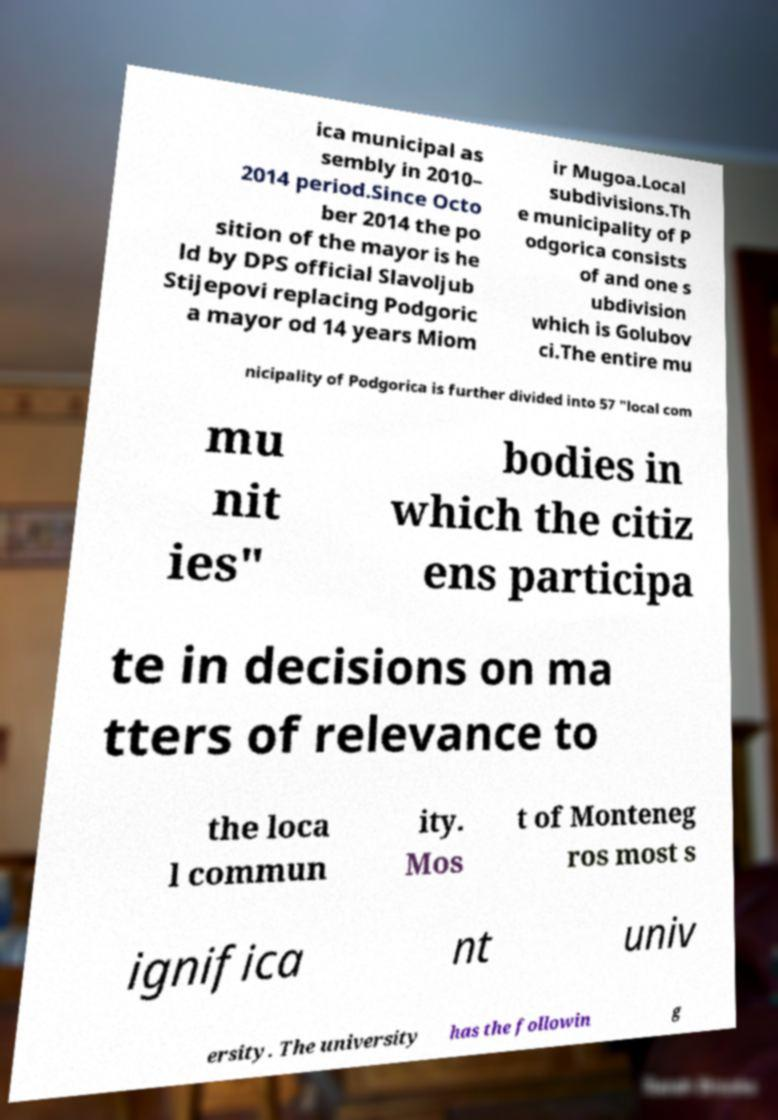For documentation purposes, I need the text within this image transcribed. Could you provide that? ica municipal as sembly in 2010– 2014 period.Since Octo ber 2014 the po sition of the mayor is he ld by DPS official Slavoljub Stijepovi replacing Podgoric a mayor od 14 years Miom ir Mugoa.Local subdivisions.Th e municipality of P odgorica consists of and one s ubdivision which is Golubov ci.The entire mu nicipality of Podgorica is further divided into 57 "local com mu nit ies" bodies in which the citiz ens participa te in decisions on ma tters of relevance to the loca l commun ity. Mos t of Monteneg ros most s ignifica nt univ ersity. The university has the followin g 